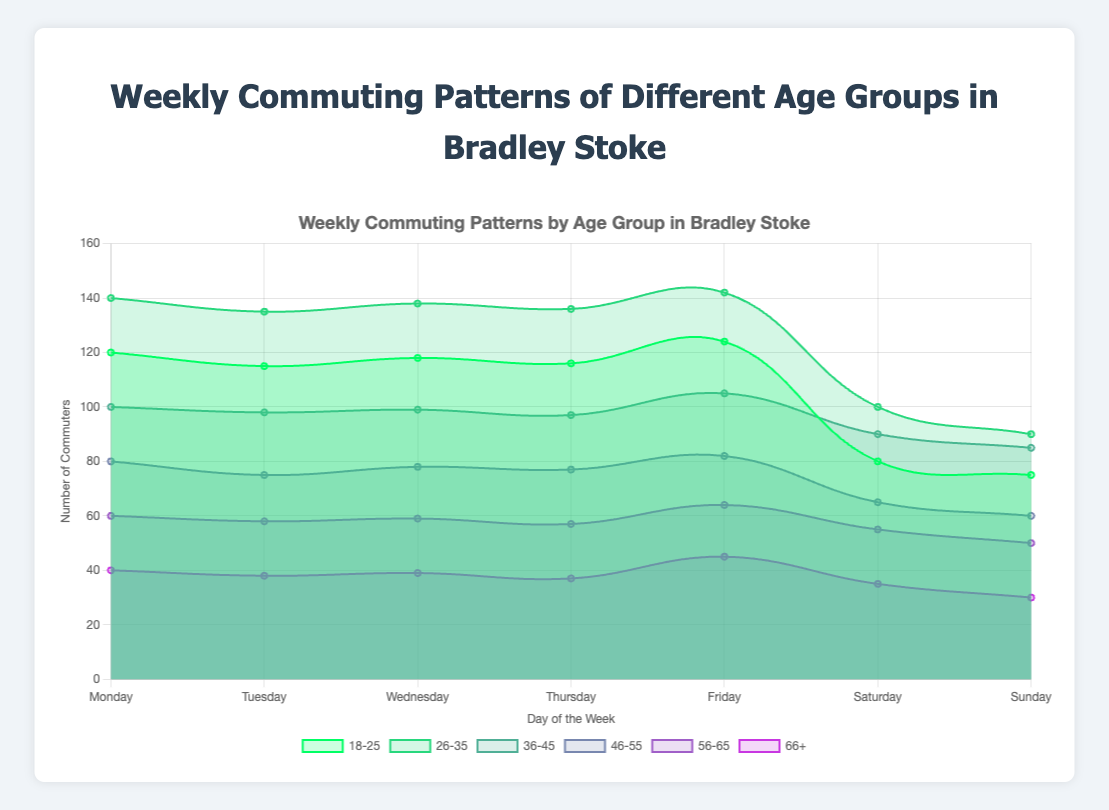What is the title of the figure? The title of the figure is displayed at the top of the chart. It summarizes the content and focus of the data visualization.
Answer: Weekly Commuting Patterns of Different Age Groups in Bradley Stoke On which day does the age group 18-25 have the highest number of commuters? Check the area corresponding to the age group 18-25 across the days of the week and identify the peak value.
Answer: Friday Which age group has the lowest number of commuters on Sunday? Look at the data lines and areas for each age group on Sunday and identify the lowest point.
Answer: 66+ What is the total number of commuters for the age group 26-35 from Monday to Wednesday? Add the values of commuters for Monday, Tuesday, and Wednesday for the age group 26-35 (140 + 135 + 138).
Answer: 413 Compare the number of commuters on Monday and Friday for the age group 46-55. Which day has more commuters? Compare the commuter values for Monday and Friday for the age group 46-55 (80 vs 82).
Answer: Friday Which age group shows the most variation in the number of commuters between weekdays and weekends? Look for the age group with the largest difference in values between weekdays (Monday-Friday) and weekends (Saturday-Sunday). Calculating differences, age group 18-25 has a significant drop on weekends compared to weekdays.
Answer: 18-25 What is the average number of commuters for the age group 36-45 over the entire week? Add the values for all days for the age group 36-45 and divide by 7 (100 + 98 + 99 + 97 + 105 + 90 + 85) / 7.
Answer: 96.29 Which age group has the steadiest (least fluctuating) number of commuters throughout the week? Examine the chart and look at each age group's line for consistency (least peaks and troughs). The age group 56-65 has a fairly steady line.
Answer: 56-65 How many more commuters are there on Wednesday for age group 26-35 compared to age group 46-55? Subtract the number of commuters of age group 46-55 from age group 26-35 on Wednesday (138 - 78).
Answer: 60 